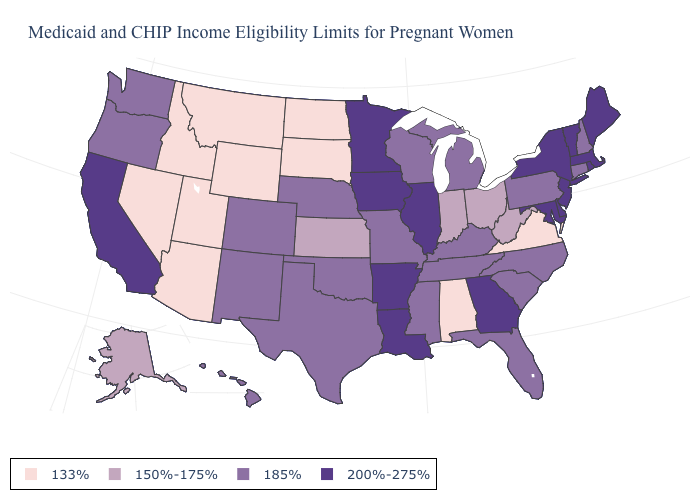What is the highest value in the West ?
Give a very brief answer. 200%-275%. What is the value of Ohio?
Keep it brief. 150%-175%. Does Montana have the lowest value in the West?
Concise answer only. Yes. Does Utah have the highest value in the West?
Short answer required. No. What is the value of California?
Write a very short answer. 200%-275%. Does Alabama have the lowest value in the South?
Be succinct. Yes. What is the lowest value in the South?
Quick response, please. 133%. Does Maine have the highest value in the USA?
Keep it brief. Yes. Does Louisiana have the same value as New Jersey?
Be succinct. Yes. Name the states that have a value in the range 200%-275%?
Concise answer only. Arkansas, California, Delaware, Georgia, Illinois, Iowa, Louisiana, Maine, Maryland, Massachusetts, Minnesota, New Jersey, New York, Rhode Island, Vermont. Name the states that have a value in the range 150%-175%?
Quick response, please. Alaska, Indiana, Kansas, Ohio, West Virginia. What is the value of Washington?
Write a very short answer. 185%. What is the highest value in the South ?
Answer briefly. 200%-275%. What is the value of Maine?
Keep it brief. 200%-275%. What is the value of Washington?
Give a very brief answer. 185%. 